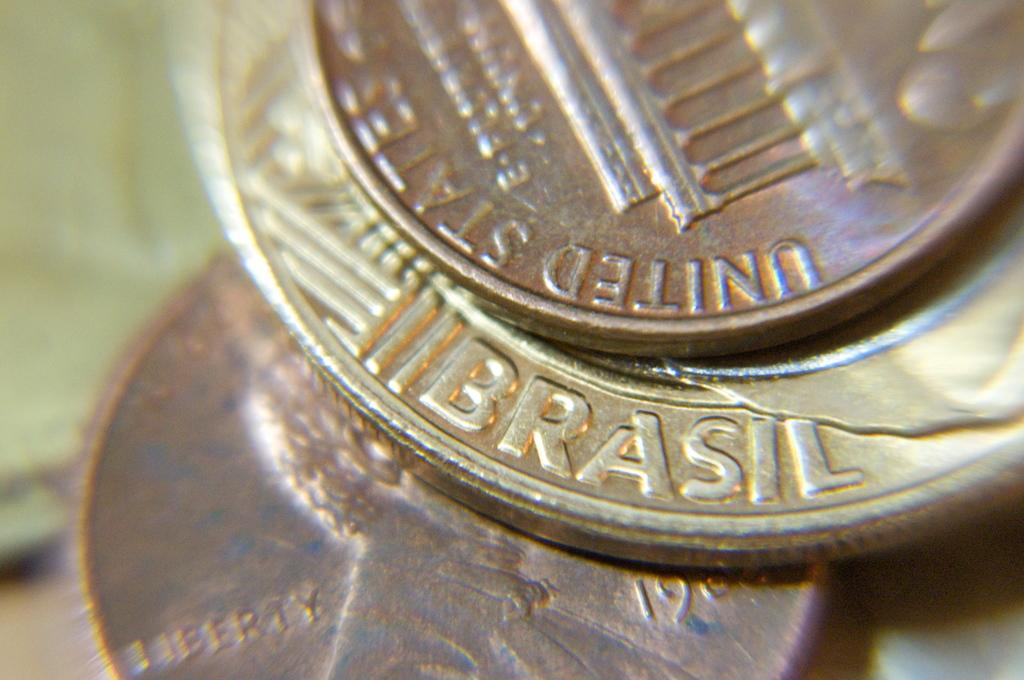<image>
Write a terse but informative summary of the picture. Two United States pennies surround a coin from Brazil. 